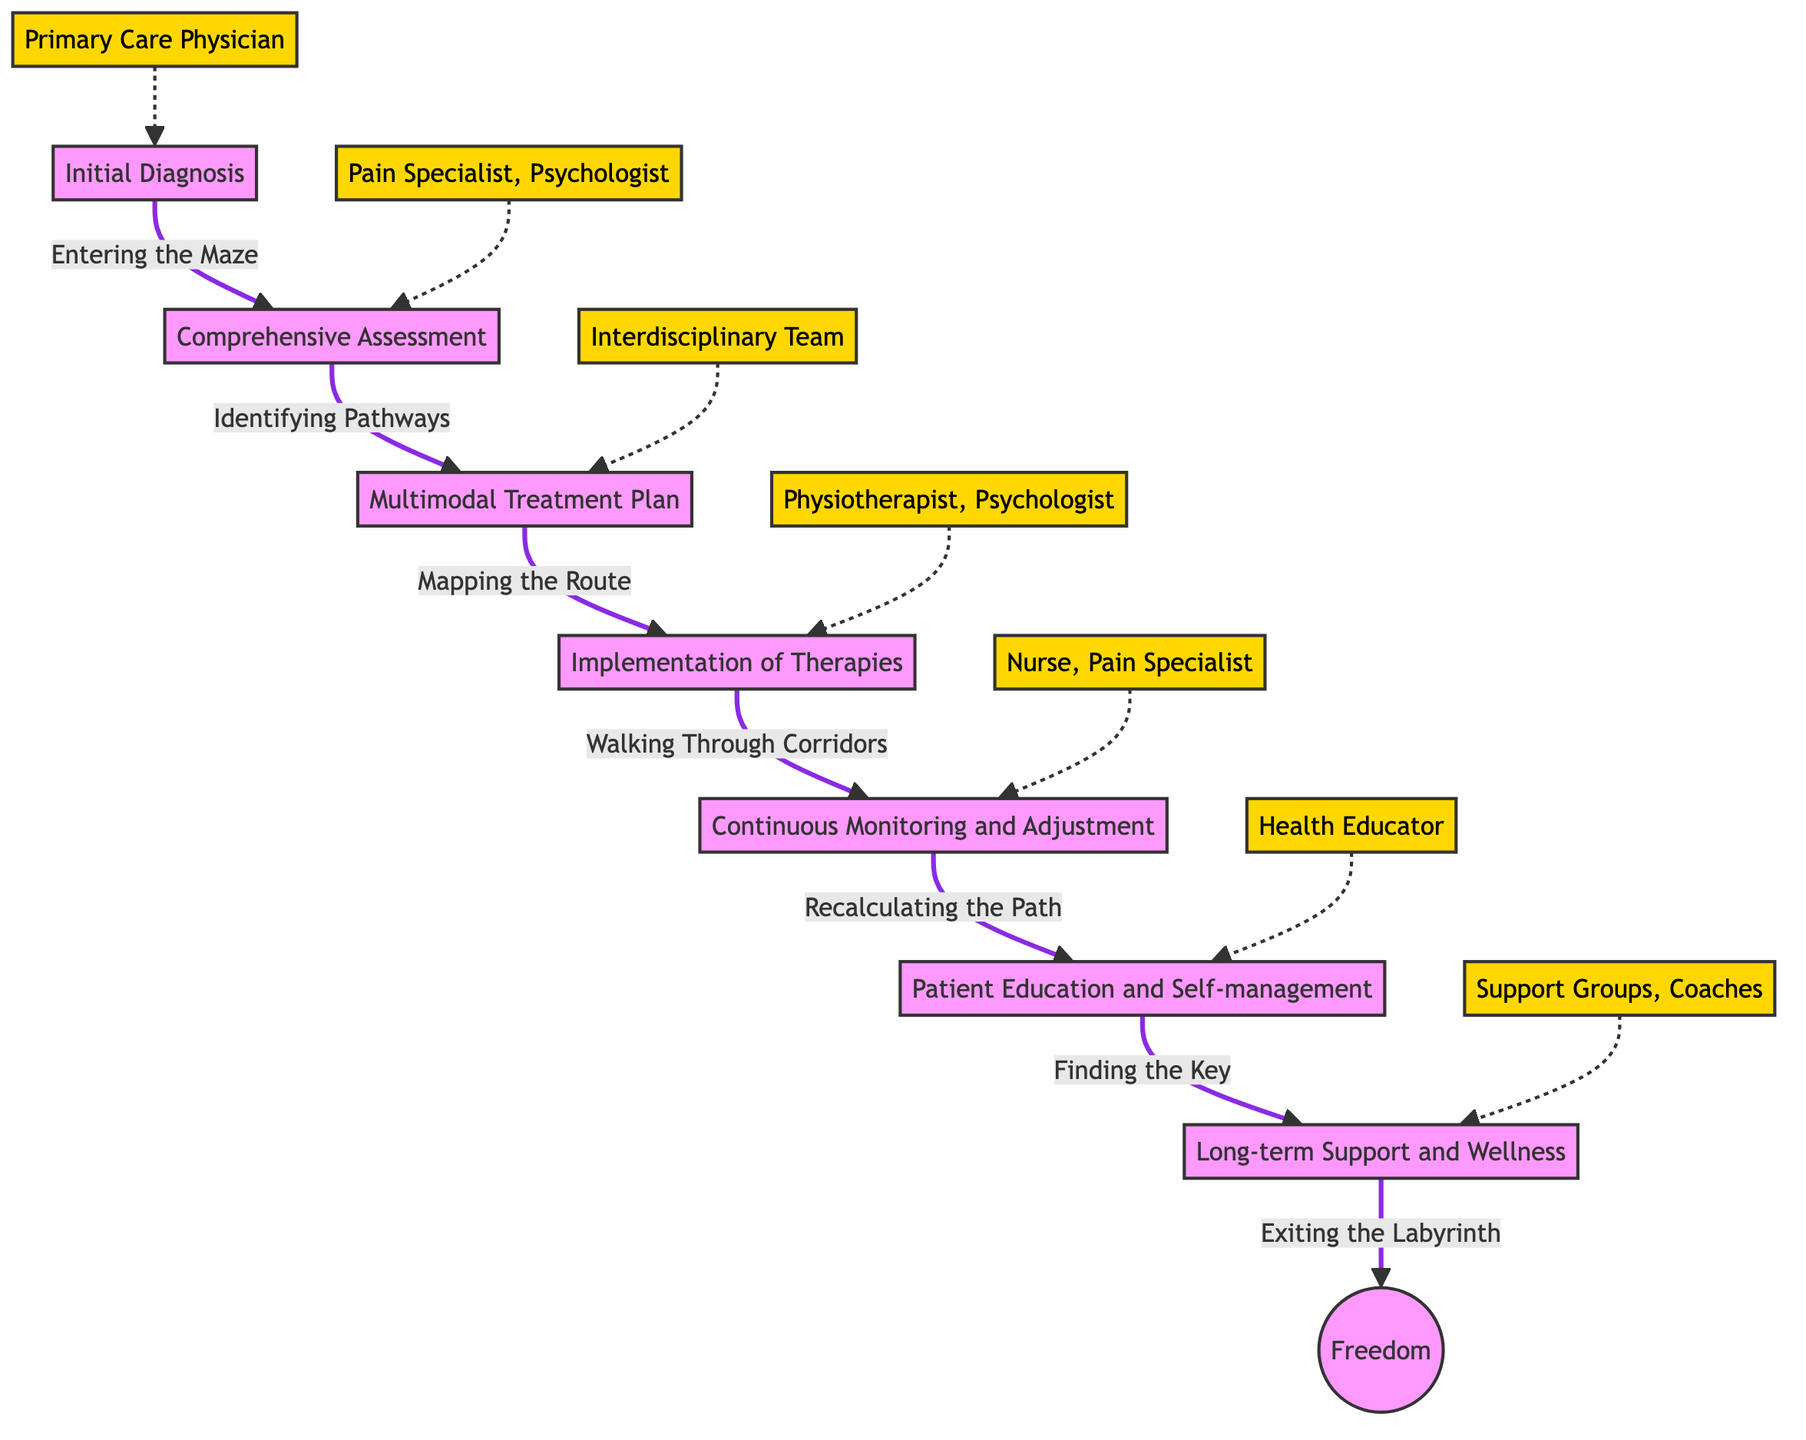What is the first stage in the pathway? The diagram shows "Initial Diagnosis" as the starting point of the clinical pathway.
Answer: Initial Diagnosis Who is the real-world entity associated with "Implementation of Therapies"? The diagram links the "Implementation of Therapies" stage with the real-world entities "Physiotherapist, Clinical Psychologist."
Answer: Physiotherapist, Clinical Psychologist How many stages are present in the pathway? Counting from the diagram, there are a total of 7 distinct stages visible in the pathway.
Answer: 7 What metaphor describes the "Continuous Monitoring and Adjustment" stage? The diagram denotes "Continuous Monitoring and Adjustment" with the metaphor "Recalculating the Path."
Answer: Recalculating the Path What stage follows "Multimodal Treatment Plan"? According to the flow of the diagram, "Implementation of Therapies" immediately follows "Multimodal Treatment Plan."
Answer: Implementation of Therapies Which real-world entity is related to "Patient Education and Self-management"? The real-world entity associated with "Patient Education and Self-management" is listed in the diagram as "Health Educator."
Answer: Health Educator What is the metaphor for the last stage of the pathway? The diagram represents the last stage, "Long-term Support and Wellness," with the metaphor "Exiting the Labyrinth."
Answer: Exiting the Labyrinth What is the relationship between "Comprehensive Assessment" and "Multimodal Treatment Plan"? The diagram illustrates a direct progression from "Comprehensive Assessment" to "Multimodal Treatment Plan," indicating they are sequential stages in the pathway.
Answer: Sequential Which stage is described as "Finding the Key"? The diagram indicates that "Patient Education and Self-management" is represented by the metaphor "Finding the Key."
Answer: Patient Education and Self-management 